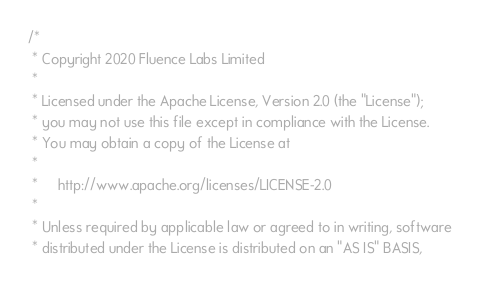<code> <loc_0><loc_0><loc_500><loc_500><_Rust_>/*
 * Copyright 2020 Fluence Labs Limited
 *
 * Licensed under the Apache License, Version 2.0 (the "License");
 * you may not use this file except in compliance with the License.
 * You may obtain a copy of the License at
 *
 *     http://www.apache.org/licenses/LICENSE-2.0
 *
 * Unless required by applicable law or agreed to in writing, software
 * distributed under the License is distributed on an "AS IS" BASIS,</code> 